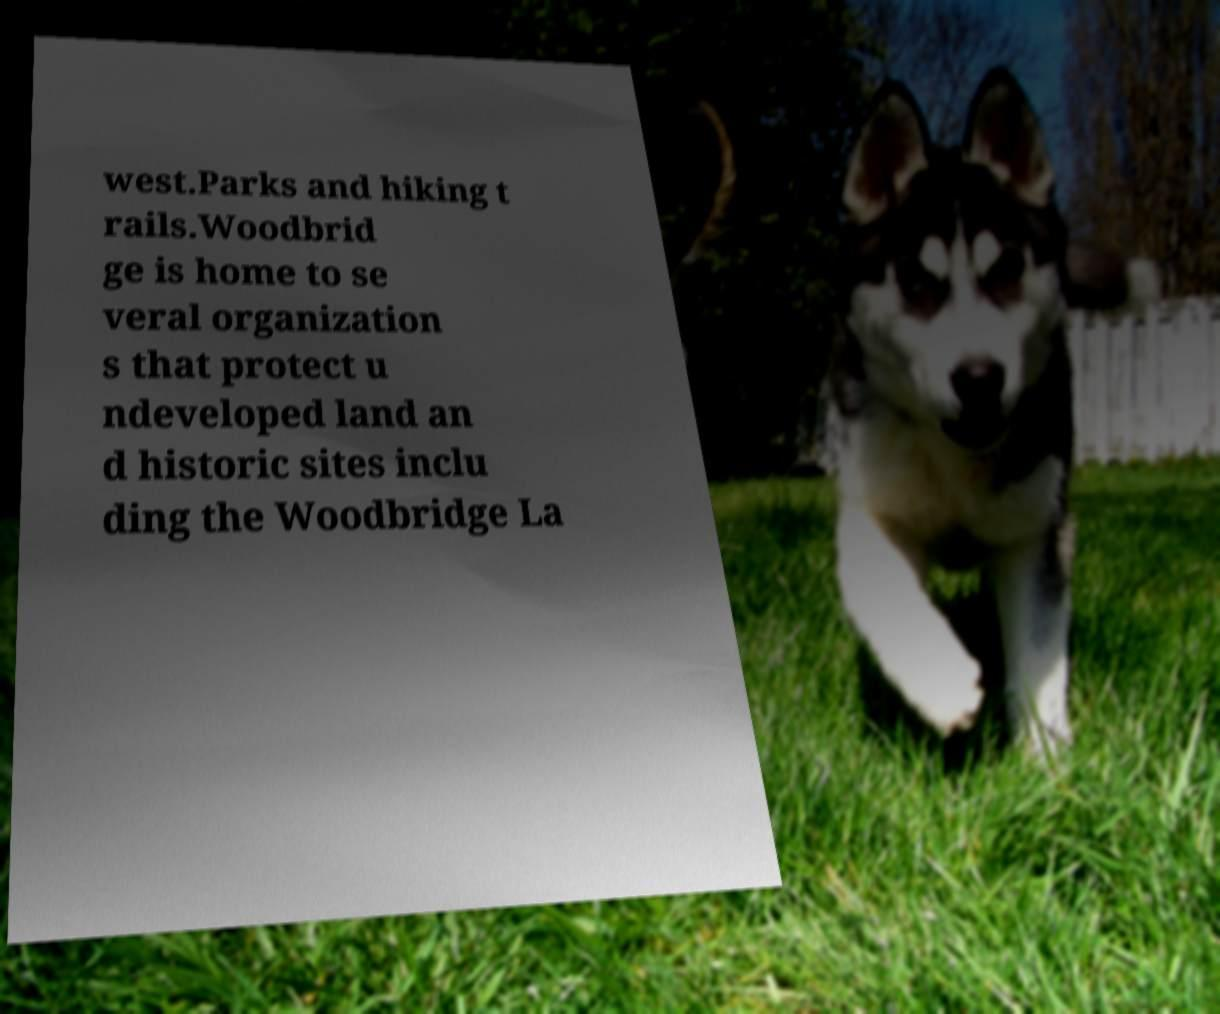For documentation purposes, I need the text within this image transcribed. Could you provide that? west.Parks and hiking t rails.Woodbrid ge is home to se veral organization s that protect u ndeveloped land an d historic sites inclu ding the Woodbridge La 